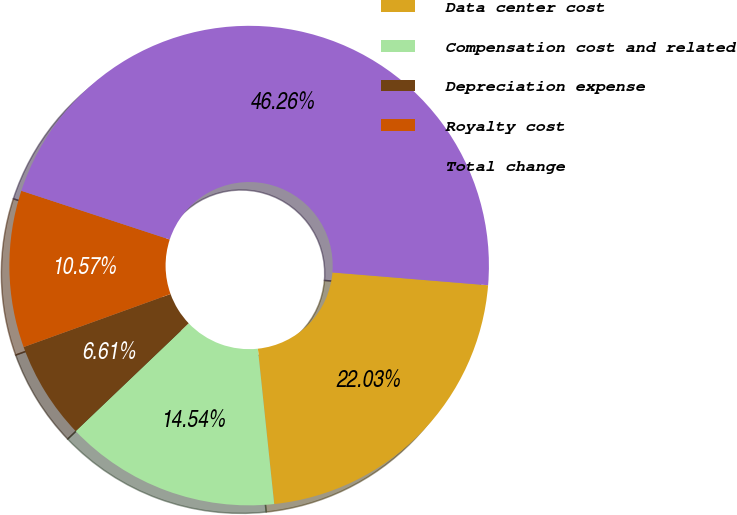<chart> <loc_0><loc_0><loc_500><loc_500><pie_chart><fcel>Data center cost<fcel>Compensation cost and related<fcel>Depreciation expense<fcel>Royalty cost<fcel>Total change<nl><fcel>22.03%<fcel>14.54%<fcel>6.61%<fcel>10.57%<fcel>46.26%<nl></chart> 